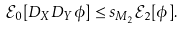<formula> <loc_0><loc_0><loc_500><loc_500>\mathcal { E } _ { 0 } [ D _ { X } D _ { Y } \phi ] \leq s _ { M _ { 2 } } \mathcal { E } _ { 2 } [ \phi ] .</formula> 